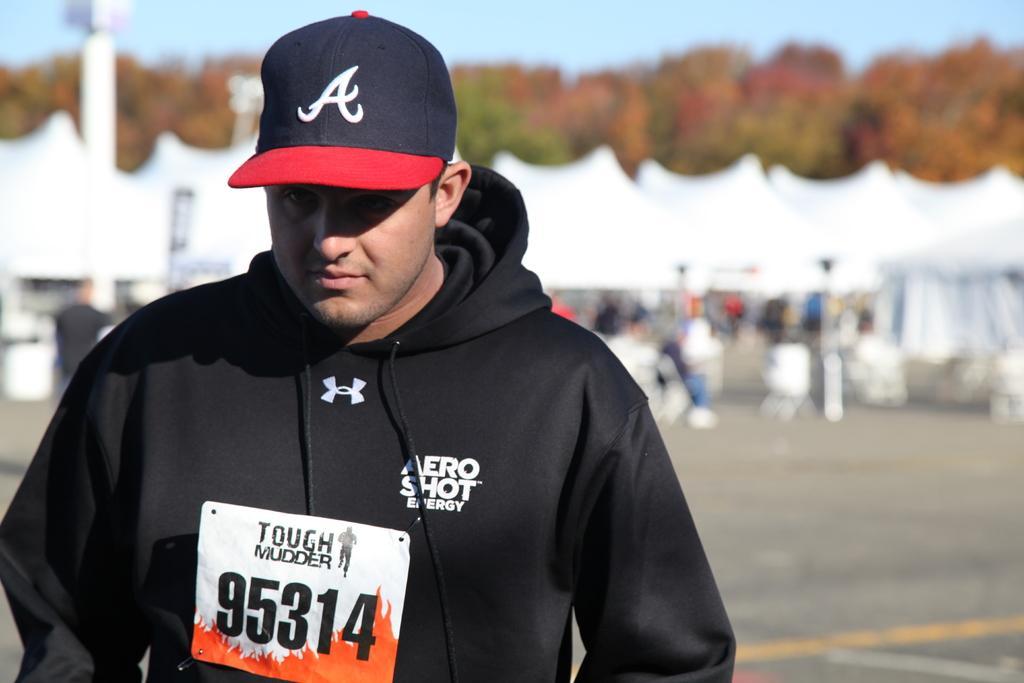Could you give a brief overview of what you see in this image? In this picture there is a person wearing black hoodie and there are trees and some other objects in the background. 